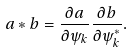<formula> <loc_0><loc_0><loc_500><loc_500>a * b = \frac { \partial a } { \partial \psi _ { k } } \frac { \partial b } { \partial \psi _ { k } ^ { * } } .</formula> 